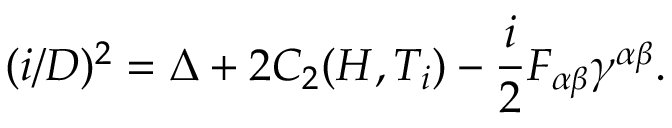Convert formula to latex. <formula><loc_0><loc_0><loc_500><loc_500>( i \slash D ) ^ { 2 } = \Delta + 2 C _ { 2 } ( H , T _ { i } ) - { \frac { i } { 2 } } F _ { \alpha \beta } \gamma ^ { \alpha \beta } .</formula> 